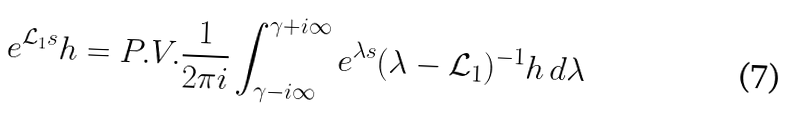Convert formula to latex. <formula><loc_0><loc_0><loc_500><loc_500>e ^ { \mathcal { L } _ { 1 } s } h = P . V . \frac { 1 } { 2 \pi i } \int _ { \gamma - i \infty } ^ { \gamma + i \infty } e ^ { \lambda s } ( \lambda - \mathcal { L } _ { 1 } ) ^ { - 1 } h \, d \lambda</formula> 